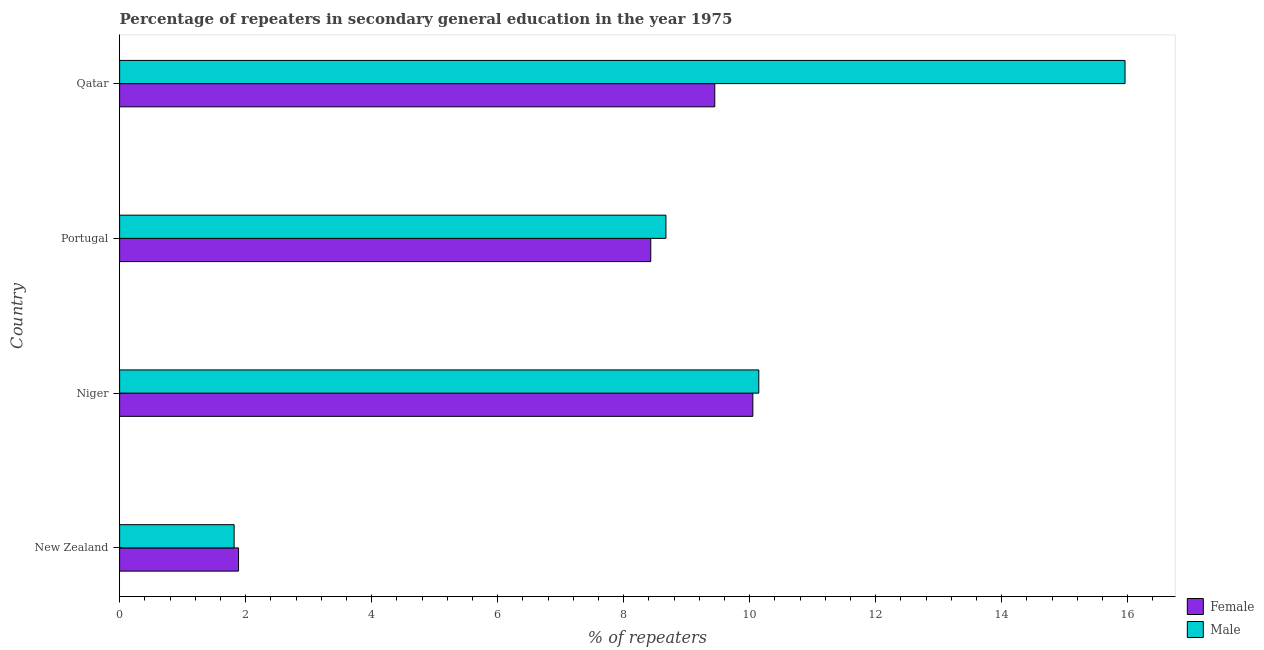How many bars are there on the 3rd tick from the top?
Your response must be concise. 2. How many bars are there on the 1st tick from the bottom?
Your answer should be compact. 2. What is the label of the 1st group of bars from the top?
Provide a succinct answer. Qatar. In how many cases, is the number of bars for a given country not equal to the number of legend labels?
Your answer should be compact. 0. What is the percentage of female repeaters in New Zealand?
Make the answer very short. 1.89. Across all countries, what is the maximum percentage of female repeaters?
Your answer should be compact. 10.05. Across all countries, what is the minimum percentage of male repeaters?
Provide a short and direct response. 1.82. In which country was the percentage of male repeaters maximum?
Provide a succinct answer. Qatar. In which country was the percentage of female repeaters minimum?
Provide a succinct answer. New Zealand. What is the total percentage of male repeaters in the graph?
Your answer should be compact. 36.59. What is the difference between the percentage of male repeaters in Niger and that in Qatar?
Your response must be concise. -5.81. What is the difference between the percentage of male repeaters in Qatar and the percentage of female repeaters in New Zealand?
Give a very brief answer. 14.07. What is the average percentage of male repeaters per country?
Make the answer very short. 9.15. What is the difference between the percentage of female repeaters and percentage of male repeaters in Portugal?
Your answer should be very brief. -0.24. What is the ratio of the percentage of male repeaters in New Zealand to that in Qatar?
Your answer should be very brief. 0.11. Is the percentage of female repeaters in New Zealand less than that in Qatar?
Your response must be concise. Yes. What is the difference between the highest and the second highest percentage of male repeaters?
Provide a short and direct response. 5.81. What is the difference between the highest and the lowest percentage of male repeaters?
Ensure brevity in your answer.  14.14. In how many countries, is the percentage of male repeaters greater than the average percentage of male repeaters taken over all countries?
Provide a short and direct response. 2. Is the sum of the percentage of male repeaters in Niger and Qatar greater than the maximum percentage of female repeaters across all countries?
Ensure brevity in your answer.  Yes. What does the 1st bar from the top in Niger represents?
Ensure brevity in your answer.  Male. What does the 2nd bar from the bottom in New Zealand represents?
Offer a very short reply. Male. How many bars are there?
Your response must be concise. 8. What is the difference between two consecutive major ticks on the X-axis?
Offer a terse response. 2. Are the values on the major ticks of X-axis written in scientific E-notation?
Give a very brief answer. No. Does the graph contain any zero values?
Offer a very short reply. No. How many legend labels are there?
Offer a very short reply. 2. How are the legend labels stacked?
Make the answer very short. Vertical. What is the title of the graph?
Offer a terse response. Percentage of repeaters in secondary general education in the year 1975. Does "Taxes on exports" appear as one of the legend labels in the graph?
Provide a short and direct response. No. What is the label or title of the X-axis?
Keep it short and to the point. % of repeaters. What is the % of repeaters in Female in New Zealand?
Give a very brief answer. 1.89. What is the % of repeaters of Male in New Zealand?
Keep it short and to the point. 1.82. What is the % of repeaters of Female in Niger?
Give a very brief answer. 10.05. What is the % of repeaters of Male in Niger?
Ensure brevity in your answer.  10.15. What is the % of repeaters in Female in Portugal?
Give a very brief answer. 8.43. What is the % of repeaters of Male in Portugal?
Ensure brevity in your answer.  8.67. What is the % of repeaters in Female in Qatar?
Keep it short and to the point. 9.45. What is the % of repeaters of Male in Qatar?
Your response must be concise. 15.96. Across all countries, what is the maximum % of repeaters in Female?
Offer a very short reply. 10.05. Across all countries, what is the maximum % of repeaters of Male?
Your response must be concise. 15.96. Across all countries, what is the minimum % of repeaters in Female?
Your answer should be very brief. 1.89. Across all countries, what is the minimum % of repeaters in Male?
Your answer should be very brief. 1.82. What is the total % of repeaters in Female in the graph?
Your answer should be very brief. 29.82. What is the total % of repeaters in Male in the graph?
Provide a succinct answer. 36.59. What is the difference between the % of repeaters in Female in New Zealand and that in Niger?
Your answer should be very brief. -8.16. What is the difference between the % of repeaters in Male in New Zealand and that in Niger?
Offer a terse response. -8.33. What is the difference between the % of repeaters in Female in New Zealand and that in Portugal?
Your answer should be compact. -6.54. What is the difference between the % of repeaters in Male in New Zealand and that in Portugal?
Make the answer very short. -6.85. What is the difference between the % of repeaters in Female in New Zealand and that in Qatar?
Provide a succinct answer. -7.56. What is the difference between the % of repeaters in Male in New Zealand and that in Qatar?
Make the answer very short. -14.14. What is the difference between the % of repeaters of Female in Niger and that in Portugal?
Make the answer very short. 1.62. What is the difference between the % of repeaters of Male in Niger and that in Portugal?
Your answer should be compact. 1.47. What is the difference between the % of repeaters in Female in Niger and that in Qatar?
Your answer should be compact. 0.6. What is the difference between the % of repeaters in Male in Niger and that in Qatar?
Provide a short and direct response. -5.81. What is the difference between the % of repeaters of Female in Portugal and that in Qatar?
Ensure brevity in your answer.  -1.02. What is the difference between the % of repeaters of Male in Portugal and that in Qatar?
Provide a short and direct response. -7.29. What is the difference between the % of repeaters of Female in New Zealand and the % of repeaters of Male in Niger?
Your answer should be compact. -8.26. What is the difference between the % of repeaters in Female in New Zealand and the % of repeaters in Male in Portugal?
Your response must be concise. -6.78. What is the difference between the % of repeaters in Female in New Zealand and the % of repeaters in Male in Qatar?
Make the answer very short. -14.07. What is the difference between the % of repeaters of Female in Niger and the % of repeaters of Male in Portugal?
Ensure brevity in your answer.  1.38. What is the difference between the % of repeaters in Female in Niger and the % of repeaters in Male in Qatar?
Provide a succinct answer. -5.91. What is the difference between the % of repeaters in Female in Portugal and the % of repeaters in Male in Qatar?
Your answer should be compact. -7.53. What is the average % of repeaters in Female per country?
Provide a succinct answer. 7.45. What is the average % of repeaters in Male per country?
Make the answer very short. 9.15. What is the difference between the % of repeaters of Female and % of repeaters of Male in New Zealand?
Provide a succinct answer. 0.07. What is the difference between the % of repeaters in Female and % of repeaters in Male in Niger?
Ensure brevity in your answer.  -0.09. What is the difference between the % of repeaters of Female and % of repeaters of Male in Portugal?
Provide a succinct answer. -0.24. What is the difference between the % of repeaters of Female and % of repeaters of Male in Qatar?
Your answer should be compact. -6.51. What is the ratio of the % of repeaters in Female in New Zealand to that in Niger?
Provide a short and direct response. 0.19. What is the ratio of the % of repeaters in Male in New Zealand to that in Niger?
Give a very brief answer. 0.18. What is the ratio of the % of repeaters of Female in New Zealand to that in Portugal?
Provide a succinct answer. 0.22. What is the ratio of the % of repeaters in Male in New Zealand to that in Portugal?
Your answer should be very brief. 0.21. What is the ratio of the % of repeaters in Female in New Zealand to that in Qatar?
Your answer should be compact. 0.2. What is the ratio of the % of repeaters of Male in New Zealand to that in Qatar?
Offer a terse response. 0.11. What is the ratio of the % of repeaters in Female in Niger to that in Portugal?
Keep it short and to the point. 1.19. What is the ratio of the % of repeaters of Male in Niger to that in Portugal?
Your answer should be compact. 1.17. What is the ratio of the % of repeaters of Female in Niger to that in Qatar?
Your answer should be compact. 1.06. What is the ratio of the % of repeaters in Male in Niger to that in Qatar?
Give a very brief answer. 0.64. What is the ratio of the % of repeaters of Female in Portugal to that in Qatar?
Offer a terse response. 0.89. What is the ratio of the % of repeaters of Male in Portugal to that in Qatar?
Offer a very short reply. 0.54. What is the difference between the highest and the second highest % of repeaters in Female?
Give a very brief answer. 0.6. What is the difference between the highest and the second highest % of repeaters of Male?
Your answer should be compact. 5.81. What is the difference between the highest and the lowest % of repeaters in Female?
Give a very brief answer. 8.16. What is the difference between the highest and the lowest % of repeaters in Male?
Keep it short and to the point. 14.14. 